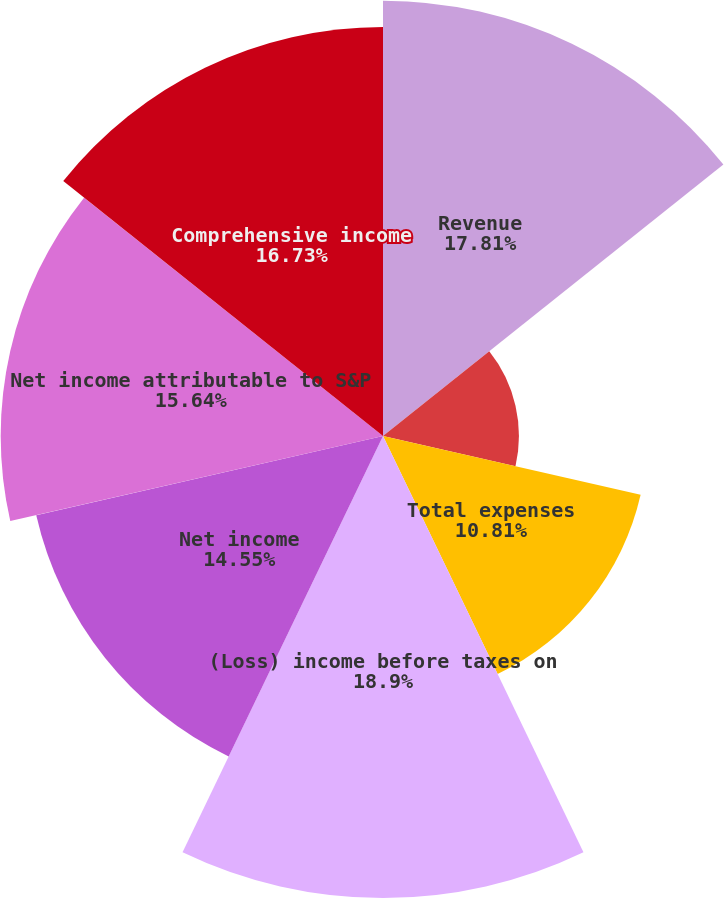<chart> <loc_0><loc_0><loc_500><loc_500><pie_chart><fcel>Revenue<fcel>Operating-related expenses<fcel>Total expenses<fcel>(Loss) income before taxes on<fcel>Net income<fcel>Net income attributable to S&P<fcel>Comprehensive income<nl><fcel>17.81%<fcel>5.56%<fcel>10.81%<fcel>18.9%<fcel>14.55%<fcel>15.64%<fcel>16.73%<nl></chart> 